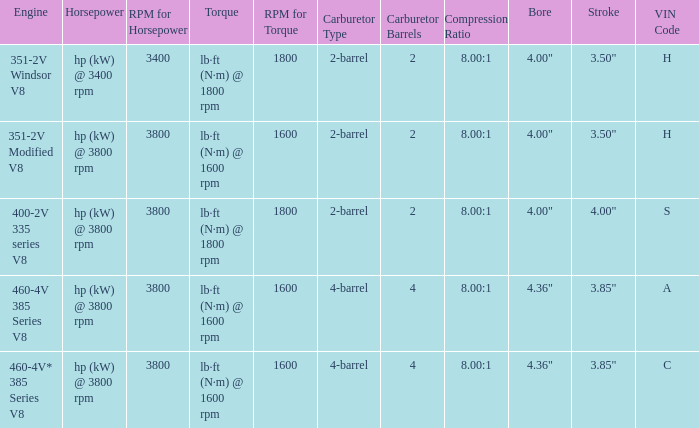What are the bore & stroke specifications for an engine with 4-barrel carburetor and VIN code of A? 4.36" x 3.85". 